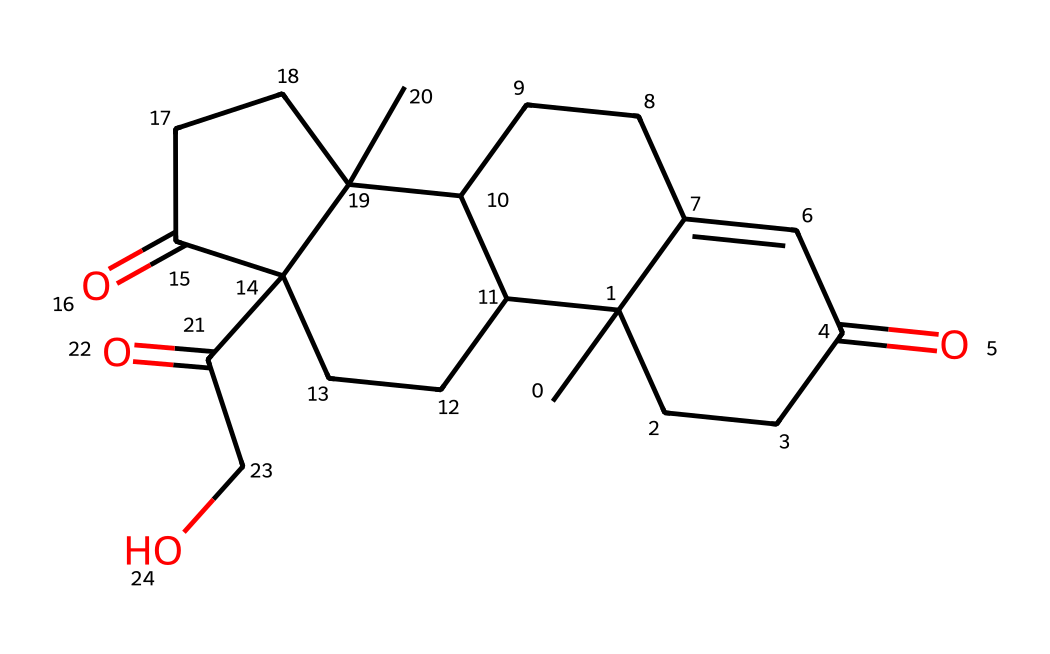How many carbon atoms are present in cortisol? To determine the number of carbon atoms in the chemical's structure, we can analyze the SMILES representation, counting each carbon symbol (C) present. Upon inspection, there are 21 carbon atoms.
Answer: 21 What is the molecular formula of cortisol? The molecular formula is derived from the counted elements in the chemical structure. From the SMILES representation, we gather C, H, and O counts, leading to C21H30O5.
Answer: C21H30O5 How many double bonds are present in cortisol? A double bond in the chemical structure is represented typically by "=" in the SMILES notation. Counting the "=" signs indicates the presence of 3 double bonds.
Answer: 3 What type of functional groups are identified in cortisol? By interpreting the structure, we can identify hydroxyl (–OH) and carbonyl (C=O) functional groups based on their characteristics in the structure; cortisol contains multiple instances of both groups.
Answer: hydroxyl and carbonyl What is the main structural feature of cortisol that indicates it is a steroid? The presence of four fused carbon rings is a characteristic structure typical of steroids, allowing us to identify cortisol as a steroid hormone.
Answer: four fused carbon rings What role does the carbonyl group play in cortisol's function? The carbonyl group contributes to the chemical reactivity and solubility of cortisol, affecting its interaction with receptors, which is central to its biological function.
Answer: reactivity and solubility What is the overall charge of cortisol under physiological pH? The functional groups present in cortisol, specifically the hydroxyl groups, do not significantly ionize at physiological pH, leading to a neutral overall charge in biological conditions.
Answer: neutral 